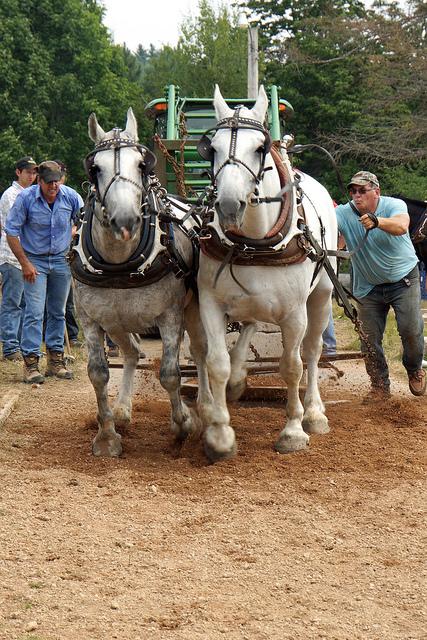How many horses are pulling the cart?
Quick response, please. 2. What is on top of all the men's heads?
Answer briefly. Hats. What color are the horses?
Short answer required. White. 